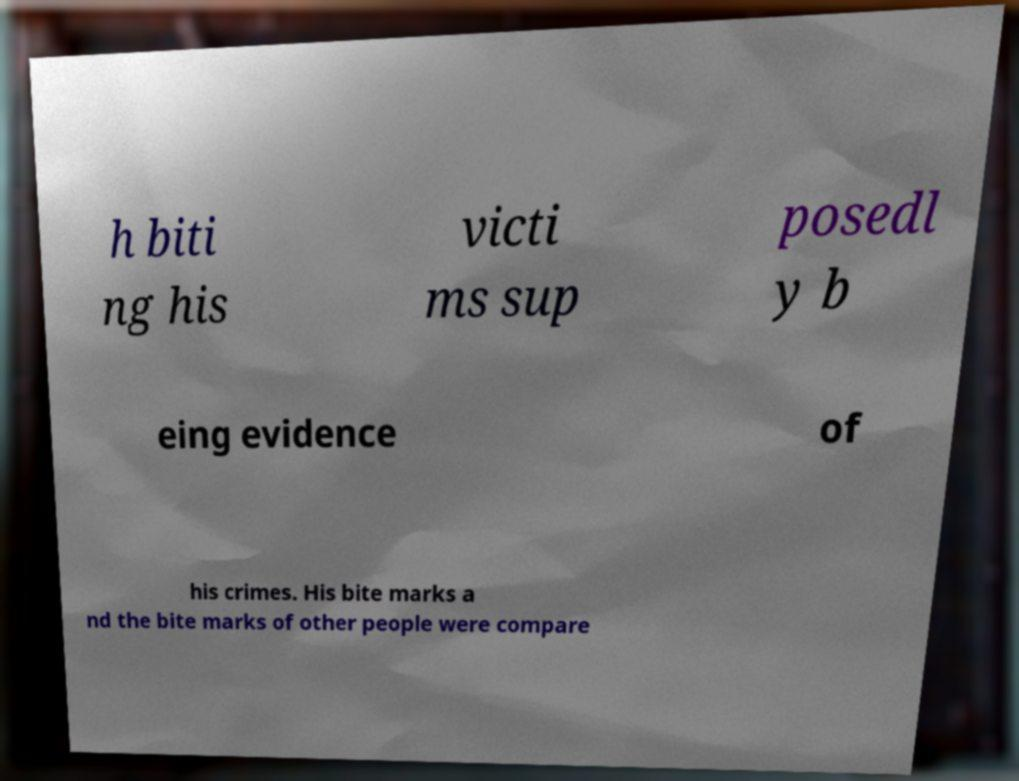There's text embedded in this image that I need extracted. Can you transcribe it verbatim? h biti ng his victi ms sup posedl y b eing evidence of his crimes. His bite marks a nd the bite marks of other people were compare 